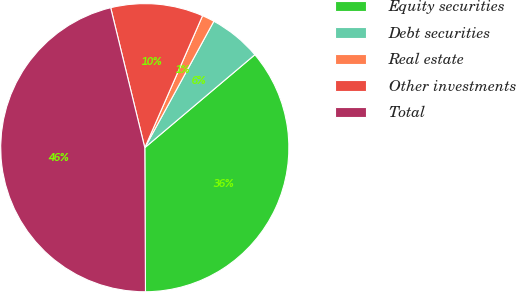Convert chart to OTSL. <chart><loc_0><loc_0><loc_500><loc_500><pie_chart><fcel>Equity securities<fcel>Debt securities<fcel>Real estate<fcel>Other investments<fcel>Total<nl><fcel>36.09%<fcel>5.88%<fcel>1.39%<fcel>10.37%<fcel>46.27%<nl></chart> 